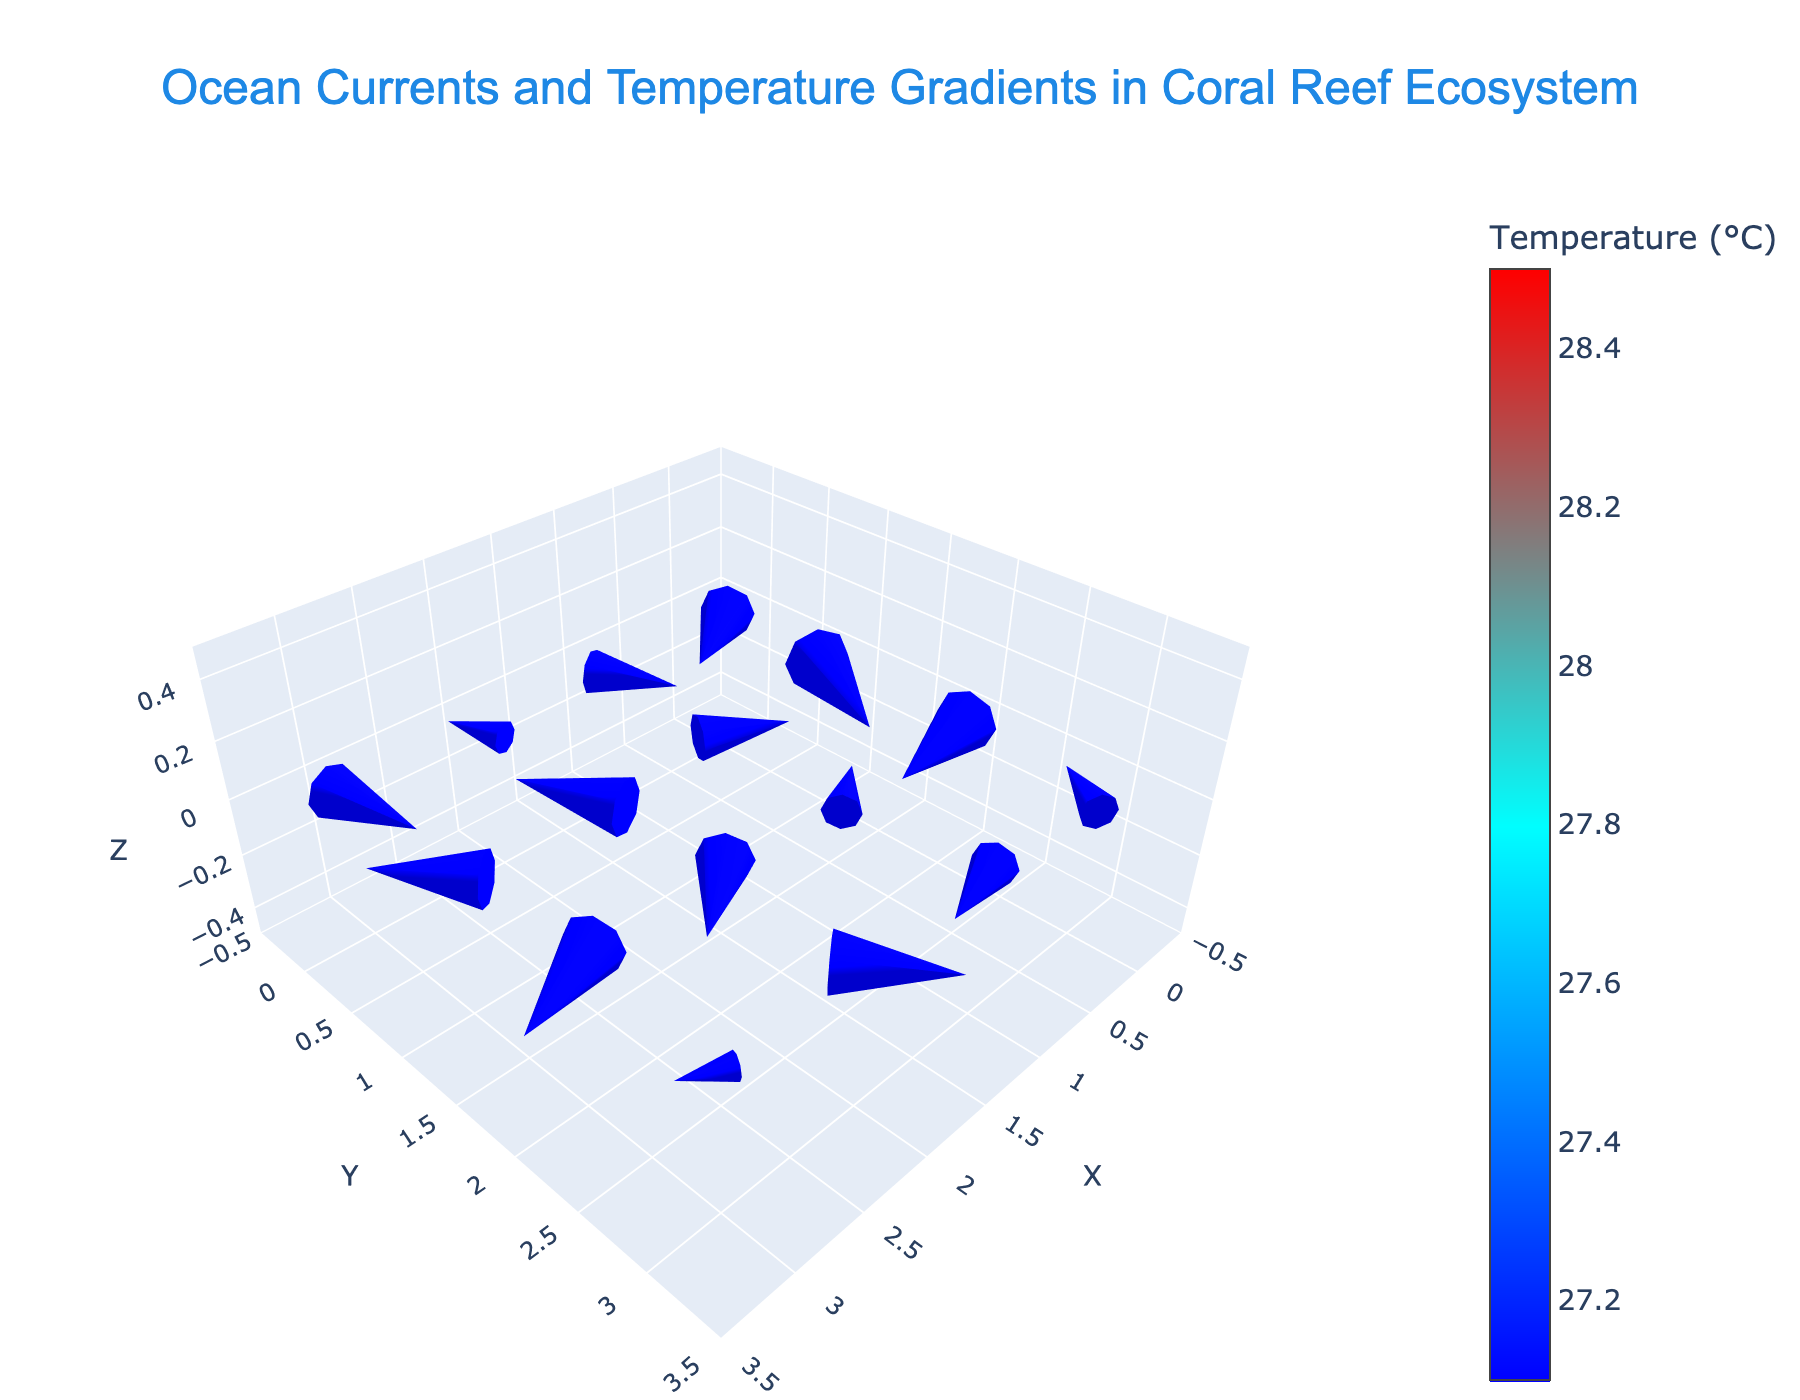what is the title of the figure? The title can be read directly from the top of the figure.
Answer: Ocean Currents and Temperature Gradients in Coral Reef Ecosystem What do the colors represent on the plot? Colors are used to represent temperature gradients, as indicated by the colorbar. Warmer colors like red represent higher temperatures, while cooler colors like blue represent lower temperatures.
Answer: Temperature How many data points are plotted? Each row in the dataset corresponds to one data point. By counting the rows, one can determine that there are 16 data points in total.
Answer: 16 What is the direction of the ocean current at point (0, 0)? The direction can be determined by observing the quiver arrow at the coordinates (0, 0). The arrow points to the right and slightly upwards.
Answer: Right and slightly upwards Which point shows the highest temperature? The highest temperature value can be identified by observing the color and referring to the colorbar. Red indicates the highest temperature, and the corresponding point is (0, 0) with a temperature of 28.5°C.
Answer: (0, 0) What is the range of the Y-axis? By looking at the axis labels, the Y-axis ranges from the minimum value around -0.5 to the maximum value around 2.5.
Answer: -0.5 to 2.5 What is the average temperature of all the data points? Adding all the temperature values from the dataset and dividing by the number of data points gives the average: (28.5 + 28.2 + 27.9 + 28.3 + 28.0 + 27.7 + 28.1 + 27.8 + 27.6 + 27.5 + 27.3 + 27.1 + 27.9 + 27.7 + 27.5 + 27.2) / 16.
Answer: 27.85°C Which point has the strongest ocean current magnitude? The magnitude of the current is calculated using the Pythagorean theorem (sqrt(u^2 + v^2)) for each point. By computing, point (0, 1) with u=0.3 and v=0.6 has the largest magnitude sqrt(0.3^2 + 0.6^2) = ~0.67.
Answer: (0, 1) In which direction do most currents move in the lower right quadrant (2, 2 to 3, 3)? Observing the quiver arrows in the coordinates 2, 2 to 3, 3, most arrows seem to point either rightwards or upwards.
Answer: Rightwards or upwards Which quadrant has the broadest range of temperatures? By examining the color variation (and referring to the colorbar) within each quadrant, the top left quadrant (0,0 to 1,1) has the broadest range, containing both warm and cooler colors.
Answer: Top left quadrant (0,0 to 1,1) How does the ocean current at (2, 0) compare to that at (2, 2) in terms of direction? By observing the quiver arrows:
- At (2,0): The arrow points slightly downwards.
- At (2,2): The arrow points upwards.
So, the directions are nearly opposite.
Answer: Nearly opposite 